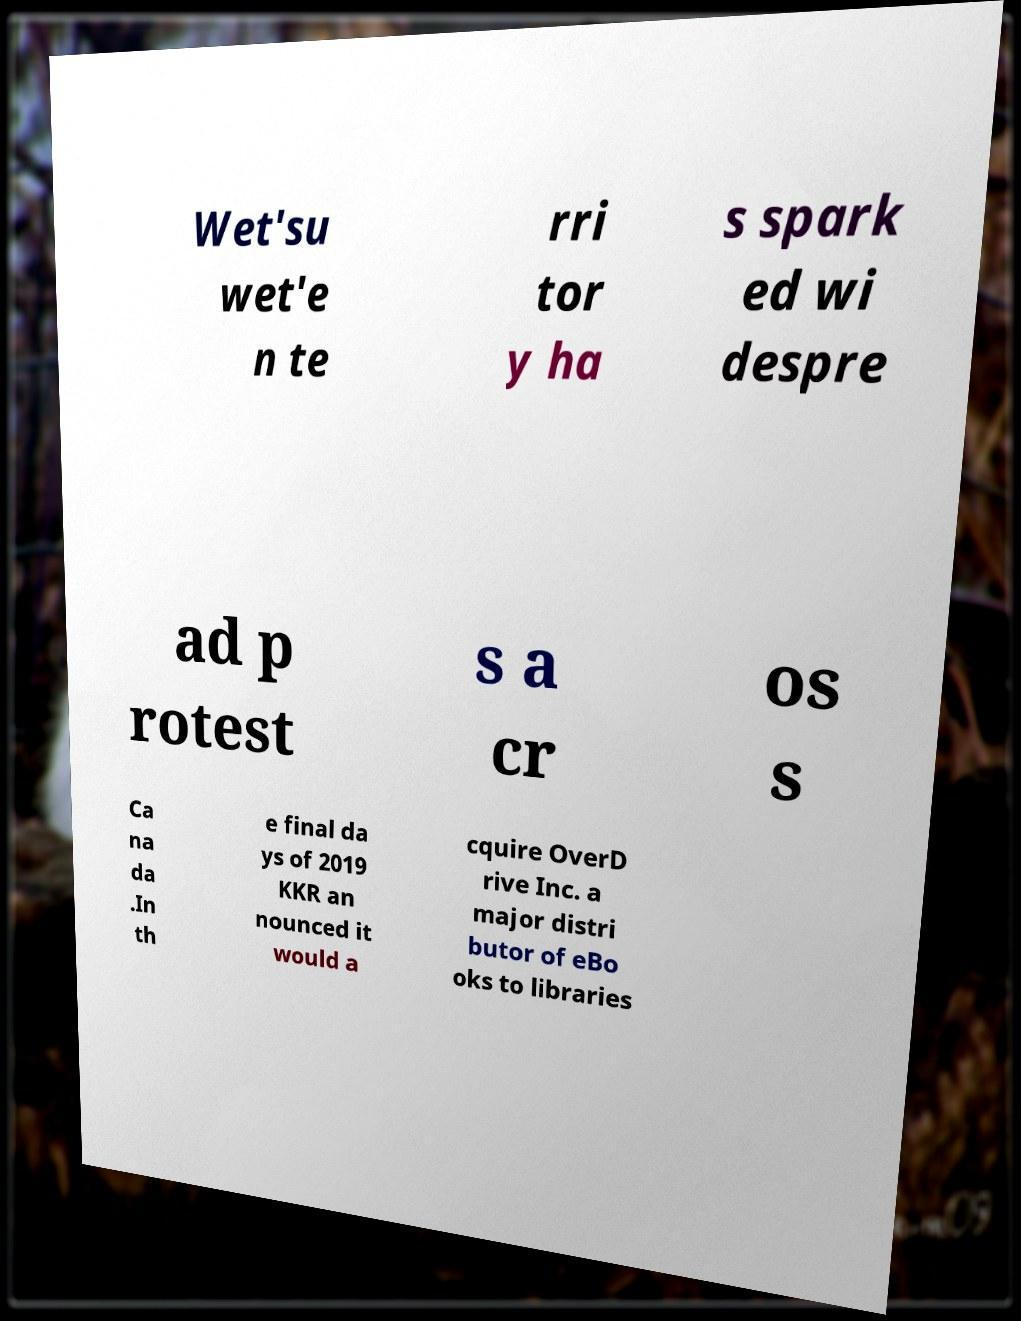Please identify and transcribe the text found in this image. Wet'su wet'e n te rri tor y ha s spark ed wi despre ad p rotest s a cr os s Ca na da .In th e final da ys of 2019 KKR an nounced it would a cquire OverD rive Inc. a major distri butor of eBo oks to libraries 